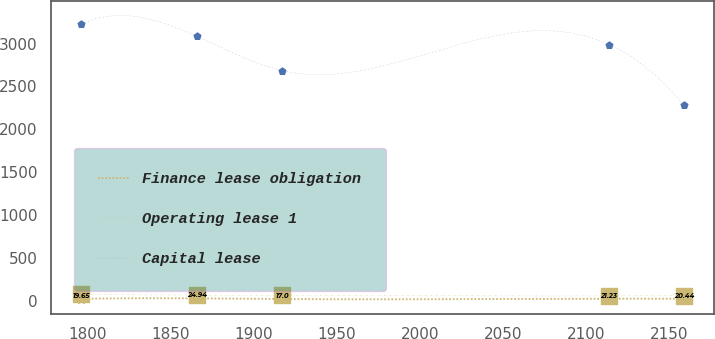<chart> <loc_0><loc_0><loc_500><loc_500><line_chart><ecel><fcel>Finance lease obligation<fcel>Operating lease 1<fcel>Capital lease<nl><fcel>1796.07<fcel>19.65<fcel>70.61<fcel>3224.17<nl><fcel>1866.03<fcel>24.94<fcel>63.16<fcel>3083.37<nl><fcel>1917.36<fcel>17<fcel>60.55<fcel>2683.98<nl><fcel>2113.82<fcel>21.23<fcel>53.75<fcel>2989<nl><fcel>2158.67<fcel>20.44<fcel>57.97<fcel>2280.44<nl></chart> 